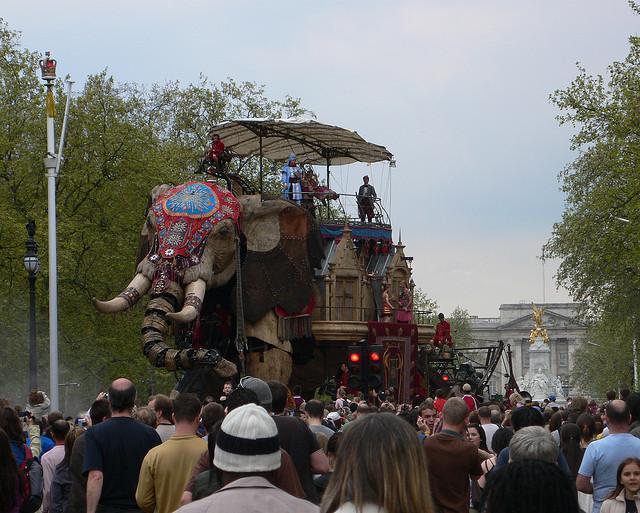How many people are visible?
Give a very brief answer. 8. 